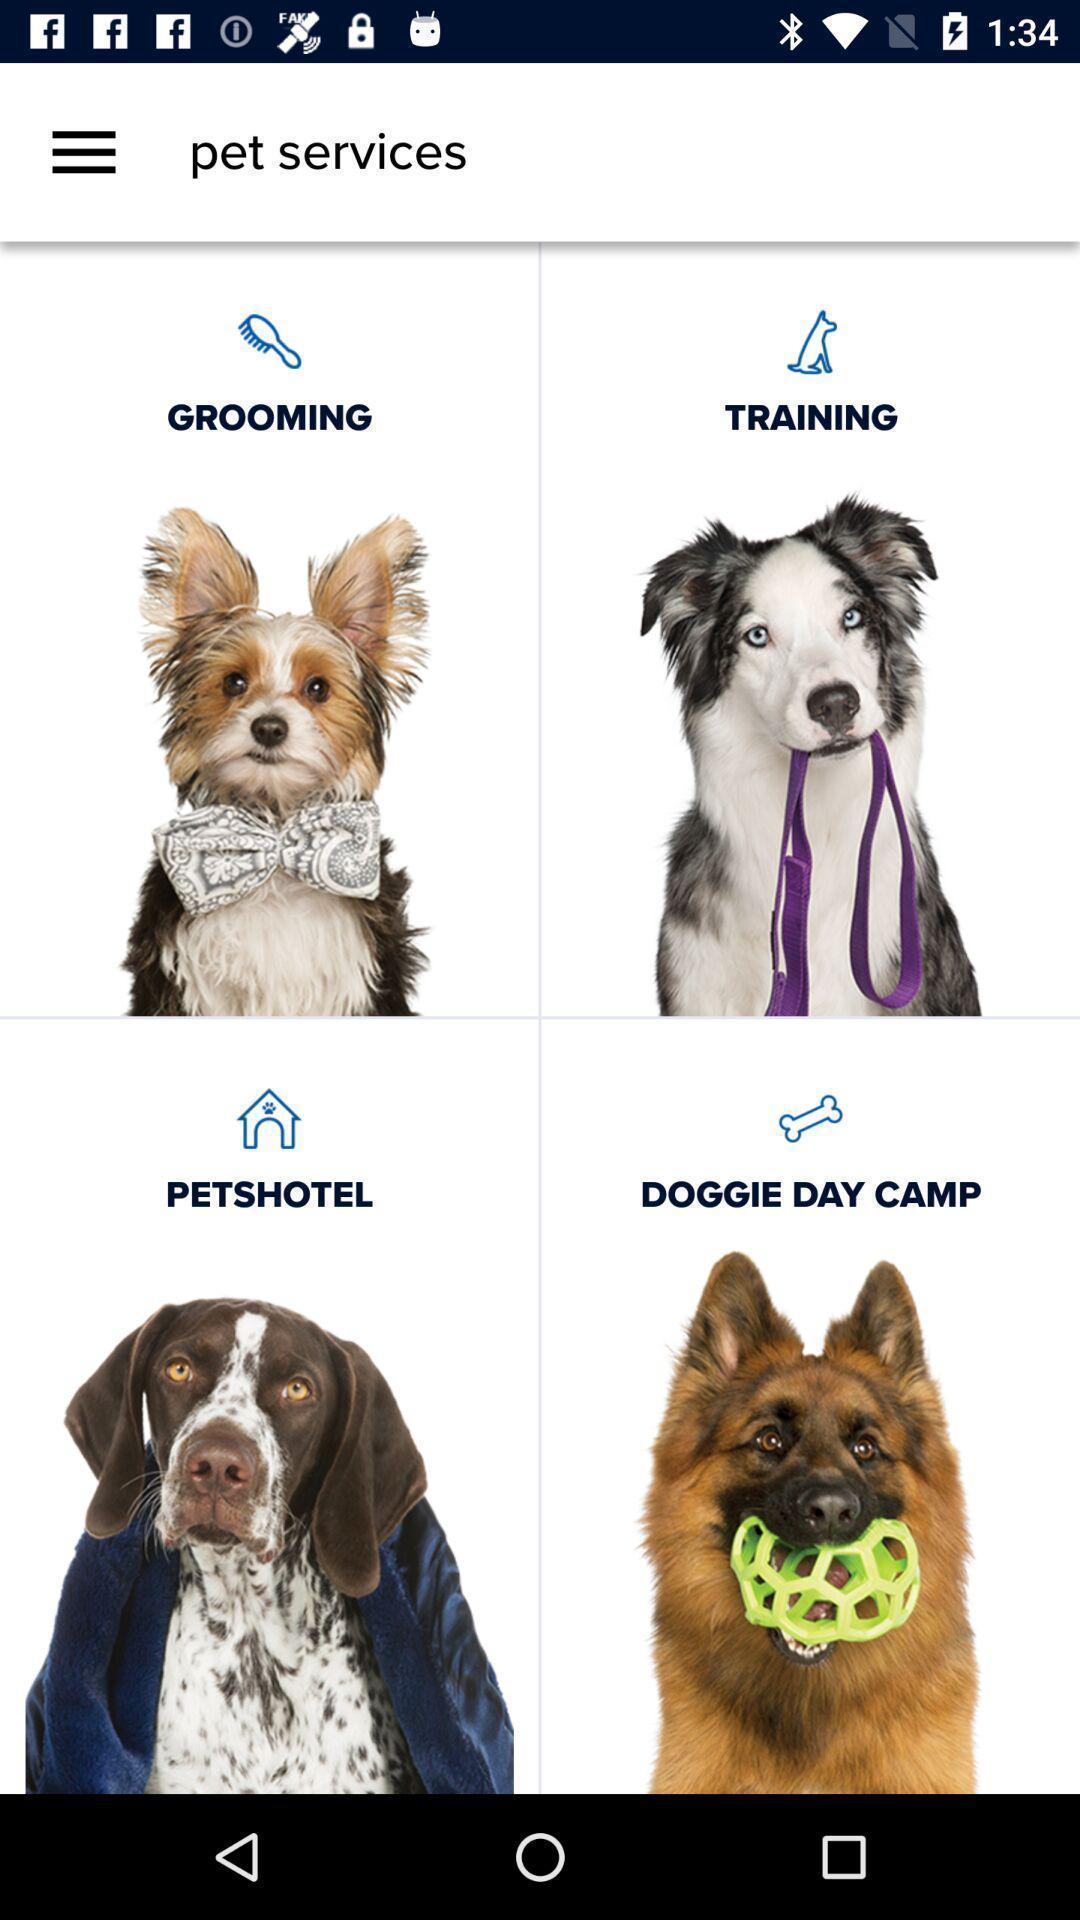Summarize the information in this screenshot. Screen showing pet services. 